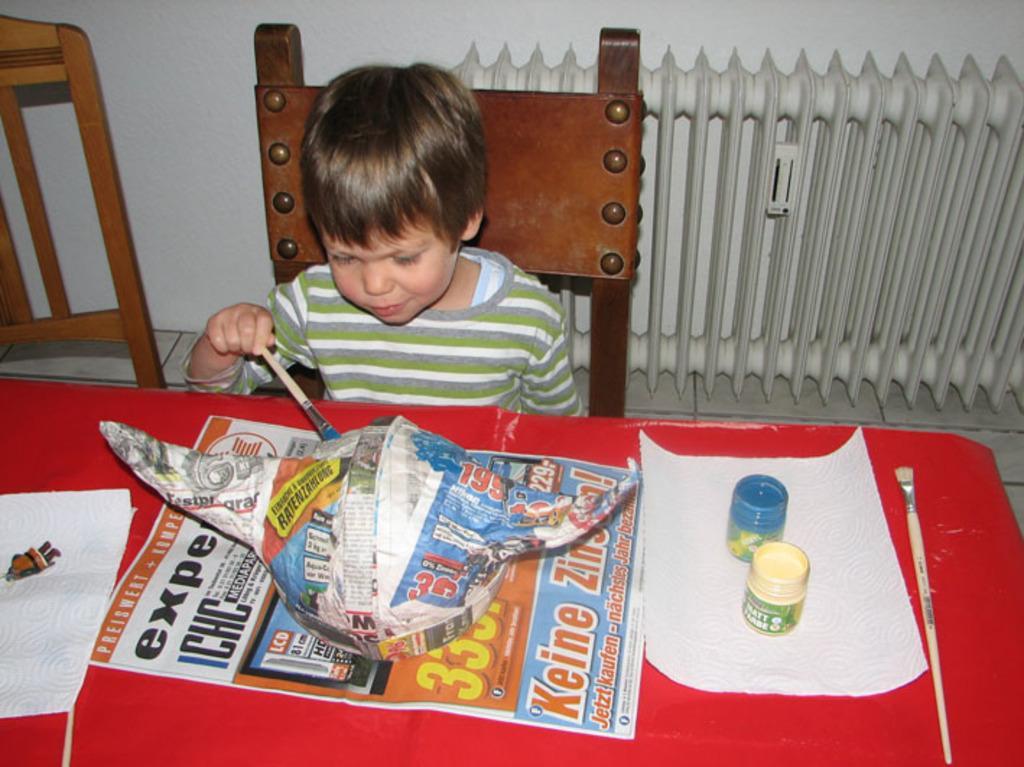How would you summarize this image in a sentence or two? In this picture I can see there is a boy sitting on the chair, he is holding a paint brush and he is painting an object which is placed in front of him. There are two paint bottles placed on a tissue, there is a red color table and there is a chair onto the left side and there is a wall in the backdrop. 